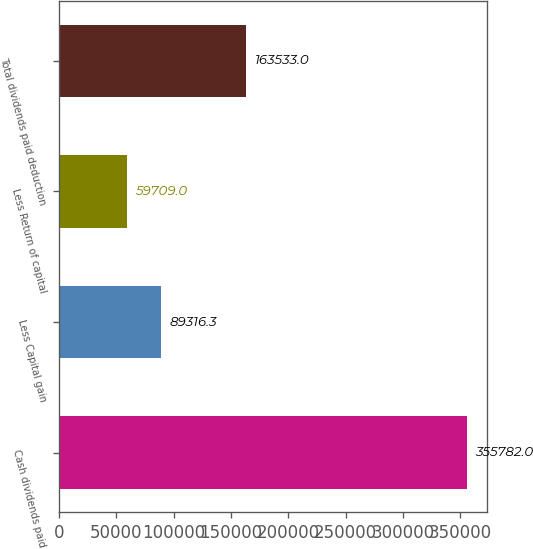<chart> <loc_0><loc_0><loc_500><loc_500><bar_chart><fcel>Cash dividends paid<fcel>Less Capital gain<fcel>Less Return of capital<fcel>Total dividends paid deduction<nl><fcel>355782<fcel>89316.3<fcel>59709<fcel>163533<nl></chart> 